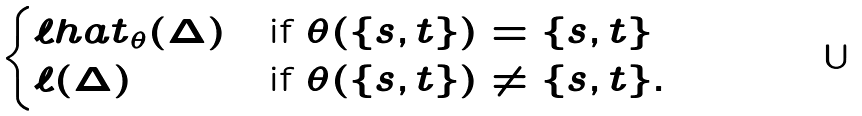<formula> <loc_0><loc_0><loc_500><loc_500>\begin{cases} \ell h a t _ { \theta } ( \Delta ) & \text {if $\theta(\{s,t\}) = \{s,t\}$} \\ \ell ( \Delta ) & \text {if $\theta(\{s,t\}) \neq \{s,t\}$} . \end{cases}</formula> 